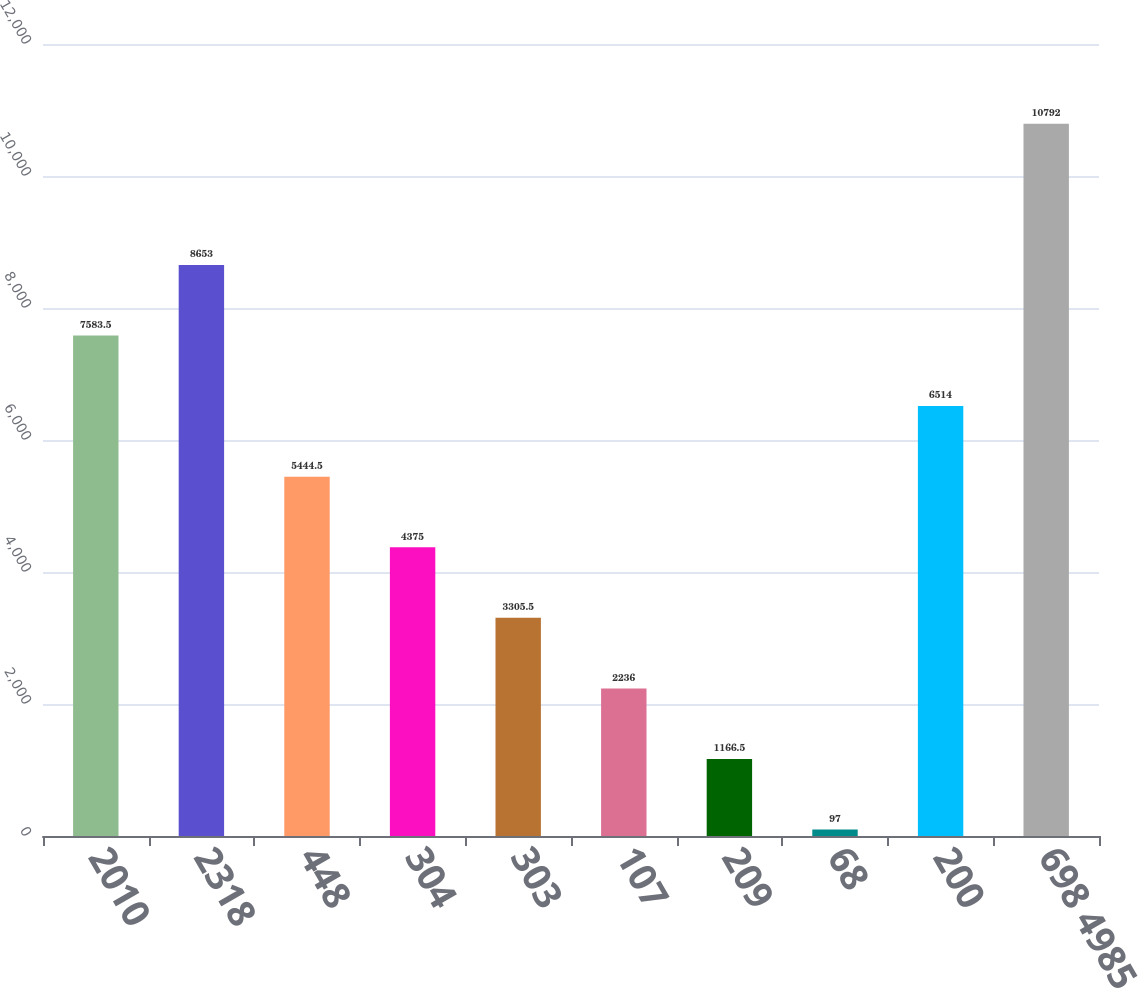Convert chart to OTSL. <chart><loc_0><loc_0><loc_500><loc_500><bar_chart><fcel>2010<fcel>2318<fcel>448<fcel>304<fcel>303<fcel>107<fcel>209<fcel>68<fcel>200<fcel>698 4985<nl><fcel>7583.5<fcel>8653<fcel>5444.5<fcel>4375<fcel>3305.5<fcel>2236<fcel>1166.5<fcel>97<fcel>6514<fcel>10792<nl></chart> 